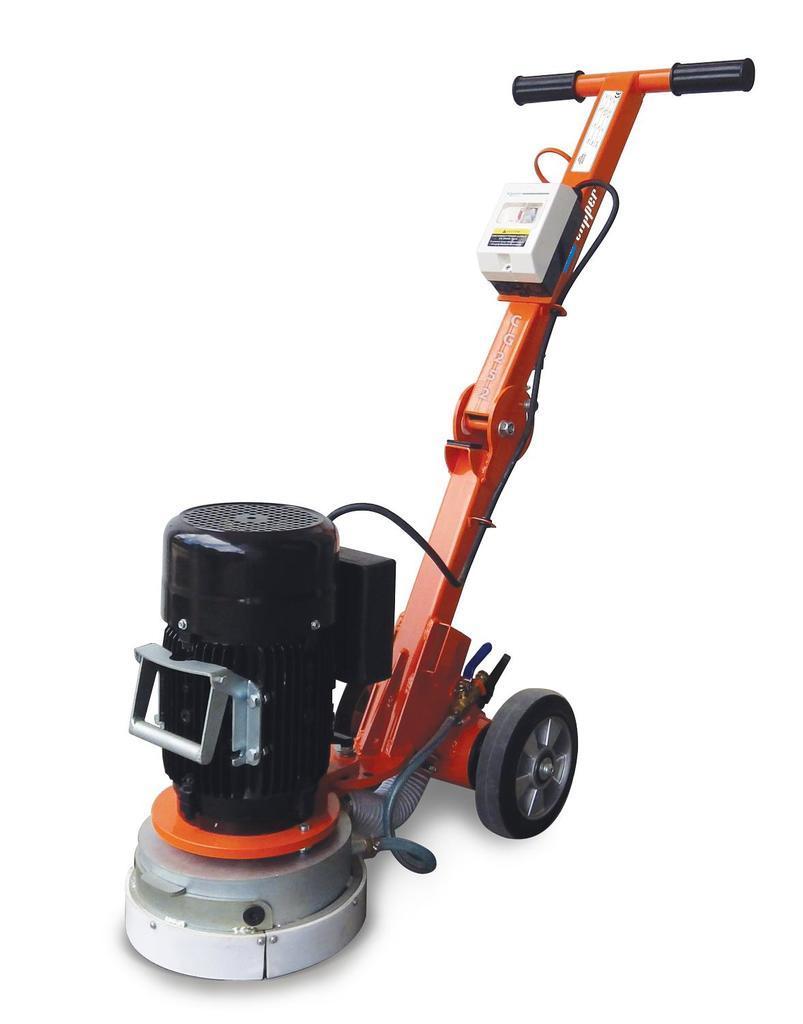Please provide a concise description of this image. It is a machine in orange color. It has wheels too. 